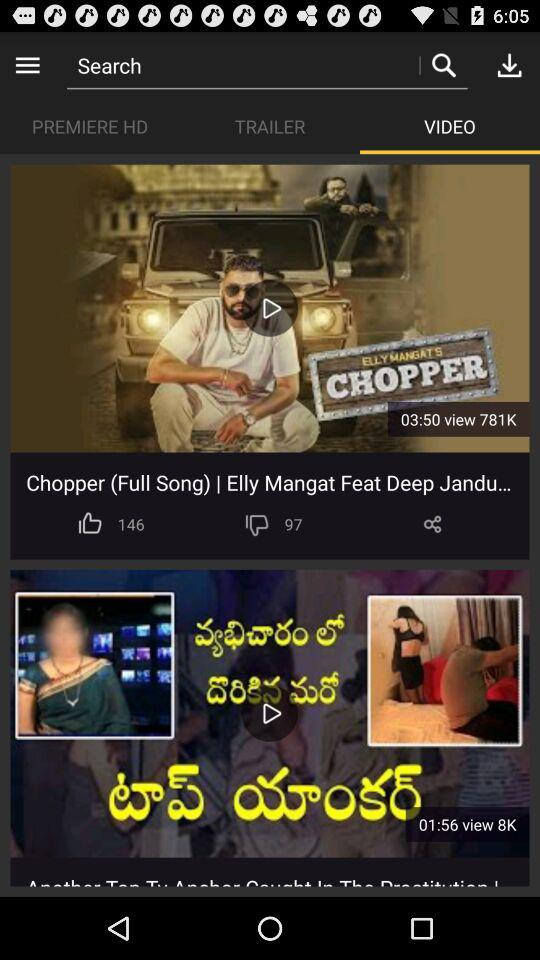What is the time duration of "Chopper (Full Song)"? The time duration of "Chopper (Full Song)" is 3 minutes and 50 seconds. 